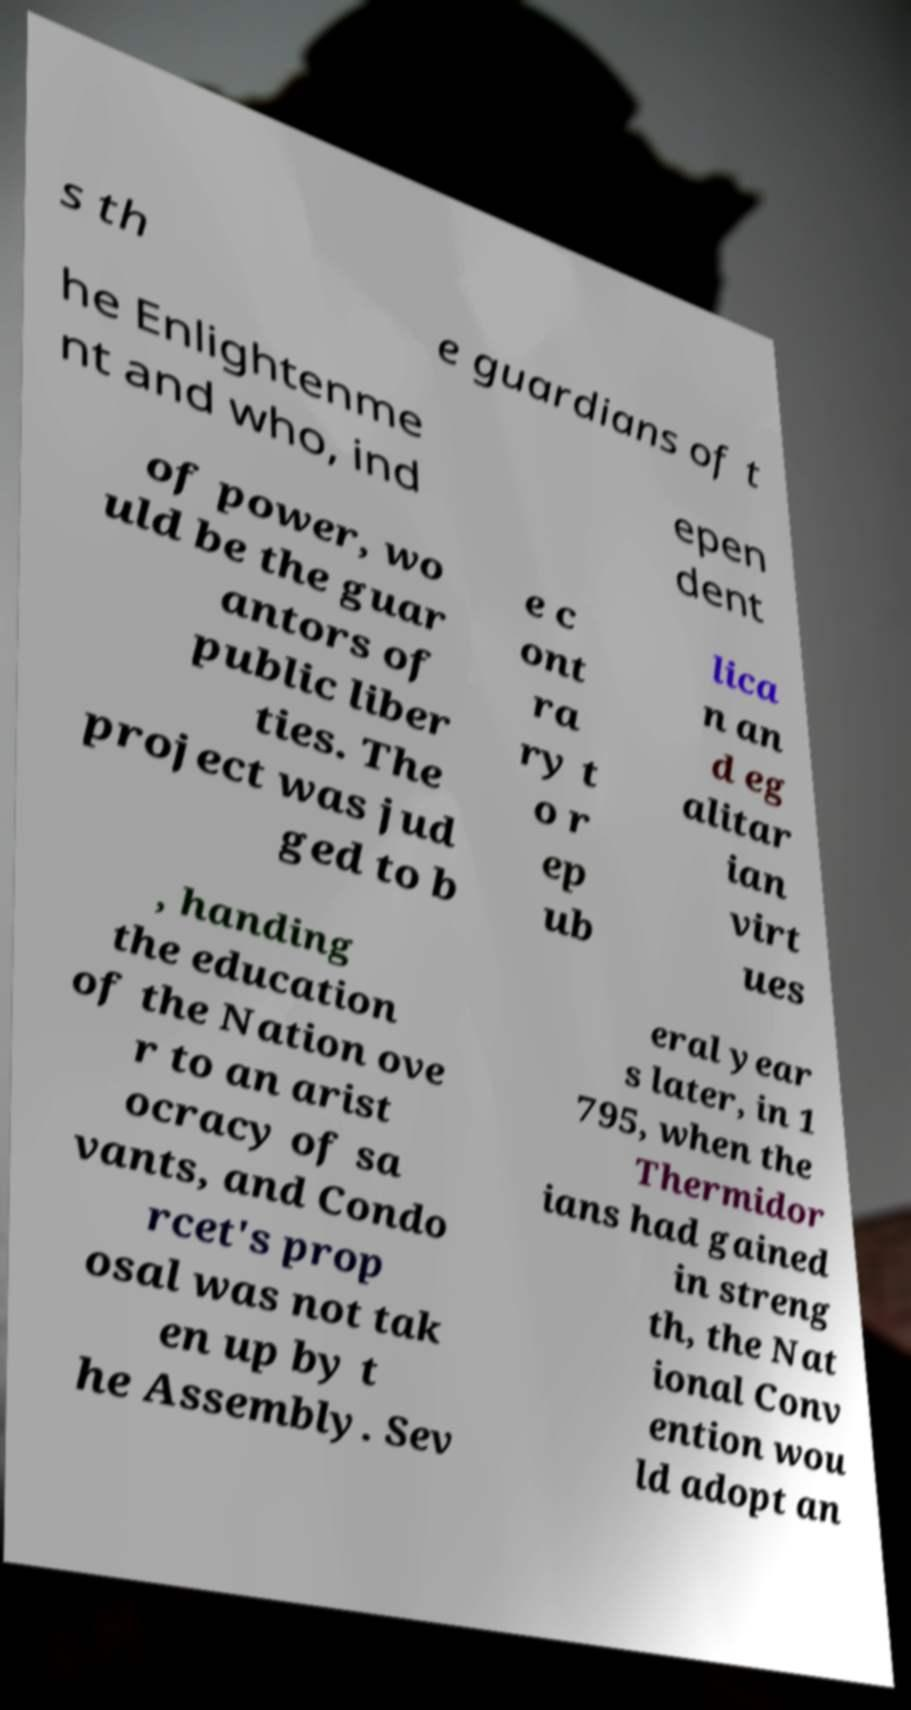Could you extract and type out the text from this image? s th e guardians of t he Enlightenme nt and who, ind epen dent of power, wo uld be the guar antors of public liber ties. The project was jud ged to b e c ont ra ry t o r ep ub lica n an d eg alitar ian virt ues , handing the education of the Nation ove r to an arist ocracy of sa vants, and Condo rcet's prop osal was not tak en up by t he Assembly. Sev eral year s later, in 1 795, when the Thermidor ians had gained in streng th, the Nat ional Conv ention wou ld adopt an 